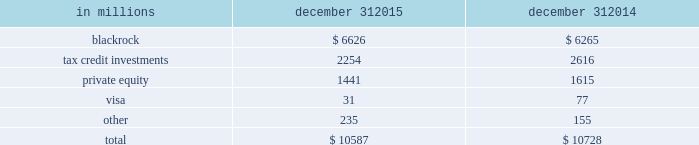An institution rated single-a by the credit rating agencies .
Given the illiquid nature of many of these types of investments , it can be a challenge to determine their fair values .
See note 7 fair value in the notes to consolidated financial statements in item 8 of this report for additional information .
Various pnc business units manage our equity and other investment activities .
Our businesses are responsible for making investment decisions within the approved policy limits and associated guidelines .
A summary of our equity investments follows : table 48 : equity investments summary in millions december 31 december 31 .
Blackrock pnc owned approximately 35 million common stock equivalent shares of blackrock equity at december 31 , 2015 , accounted for under the equity method .
The primary risk measurement , similar to other equity investments , is economic capital .
The business segments review section of this item 7 includes additional information about blackrock .
Tax credit investments included in our equity investments are direct tax credit investments and equity investments held by consolidated partnerships which totaled $ 2.3 billion at december 31 , 2015 and $ 2.6 billion at december 31 , 2014 .
These equity investment balances include unfunded commitments totaling $ 669 million and $ 717 million at december 31 , 2015 and december 31 , 2014 , respectively .
These unfunded commitments are included in other liabilities on our consolidated balance sheet .
Note 2 loan sale and servicing activities and variable interest entities in the notes to consolidated financial statements in item 8 of this report has further information on tax credit investments .
Private equity the private equity portfolio is an illiquid portfolio comprised of mezzanine and equity investments that vary by industry , stage and type of investment .
Private equity investments carried at estimated fair value totaled $ 1.4 billion at december 31 , 2015 and $ 1.6 billion at december 31 , 2014 .
As of december 31 , 2015 , $ 1.1 billion was invested directly in a variety of companies and $ .3 billion was invested indirectly through various private equity funds .
Included in direct investments are investment activities of two private equity funds that are consolidated for financial reporting purposes .
The noncontrolling interests of these funds totaled $ 170 million as of december 31 , 2015 .
The interests held in indirect private equity funds are not redeemable , but pnc may receive distributions over the life of the partnership from liquidation of the underlying investments .
See item 1 business 2013 supervision and regulation and item 1a risk factors of this report for discussion of the potential impacts of the volcker rule provisions of dodd-frank on our interests in and of private funds covered by the volcker rule .
In 2015 , pnc invested with six other banks in early warning services ( ews ) , a provider of fraud prevention and risk management solutions .
Ews then acquired clearxchange , a network through which customers send and receive person-to- person payments .
Integrating these businesses will enable us to , among other things , create a secure , real-time payments network .
Our unfunded commitments related to private equity totaled $ 126 million at december 31 , 2015 compared with $ 140 million at december 31 , 2014 .
See note 7 fair value , note 20 legal proceedings and note 21 commitments and guarantees in the notes to consolidated financial statements in item 8 of this report for additional information regarding the october 2007 visa restructuring , our involvement with judgment and loss sharing agreements with visa and certain other banks , the status of pending interchange litigation , the sales of portions of our visa class b common shares and the related swap agreements with the purchasers .
During 2015 , we sold 2.0 million visa class b common shares , in addition to the 16.5 million shares sold in previous years .
We have entered into swap agreements with the purchasers of the shares as part of these sales .
See note 7 fair value in the notes to consolidated financial statements in item 8 of this report for additional information .
At december 31 , 2015 , our investment in visa class b common shares totaled approximately 4.9 million shares and had a carrying value of $ 31 million .
Based on the december 31 , 2015 closing price of $ 77.55 for the visa class a common shares , the fair value of our total investment was approximately $ 622 million at the current conversion rate .
The visa class b common shares that we own are transferable only under limited circumstances until they can be converted into shares of the publicly traded class of stock , which cannot happen until the settlement of all of the specified litigation .
90 the pnc financial services group , inc .
2013 form 10-k .
For the blackrock common stock equivalent shares at december 31 , 2015 , accounted for under the equity method , what was the cost per share in dollars? 
Computations: (6626 / 35)
Answer: 189.31429. 